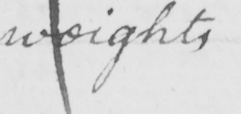Can you tell me what this handwritten text says? weights 